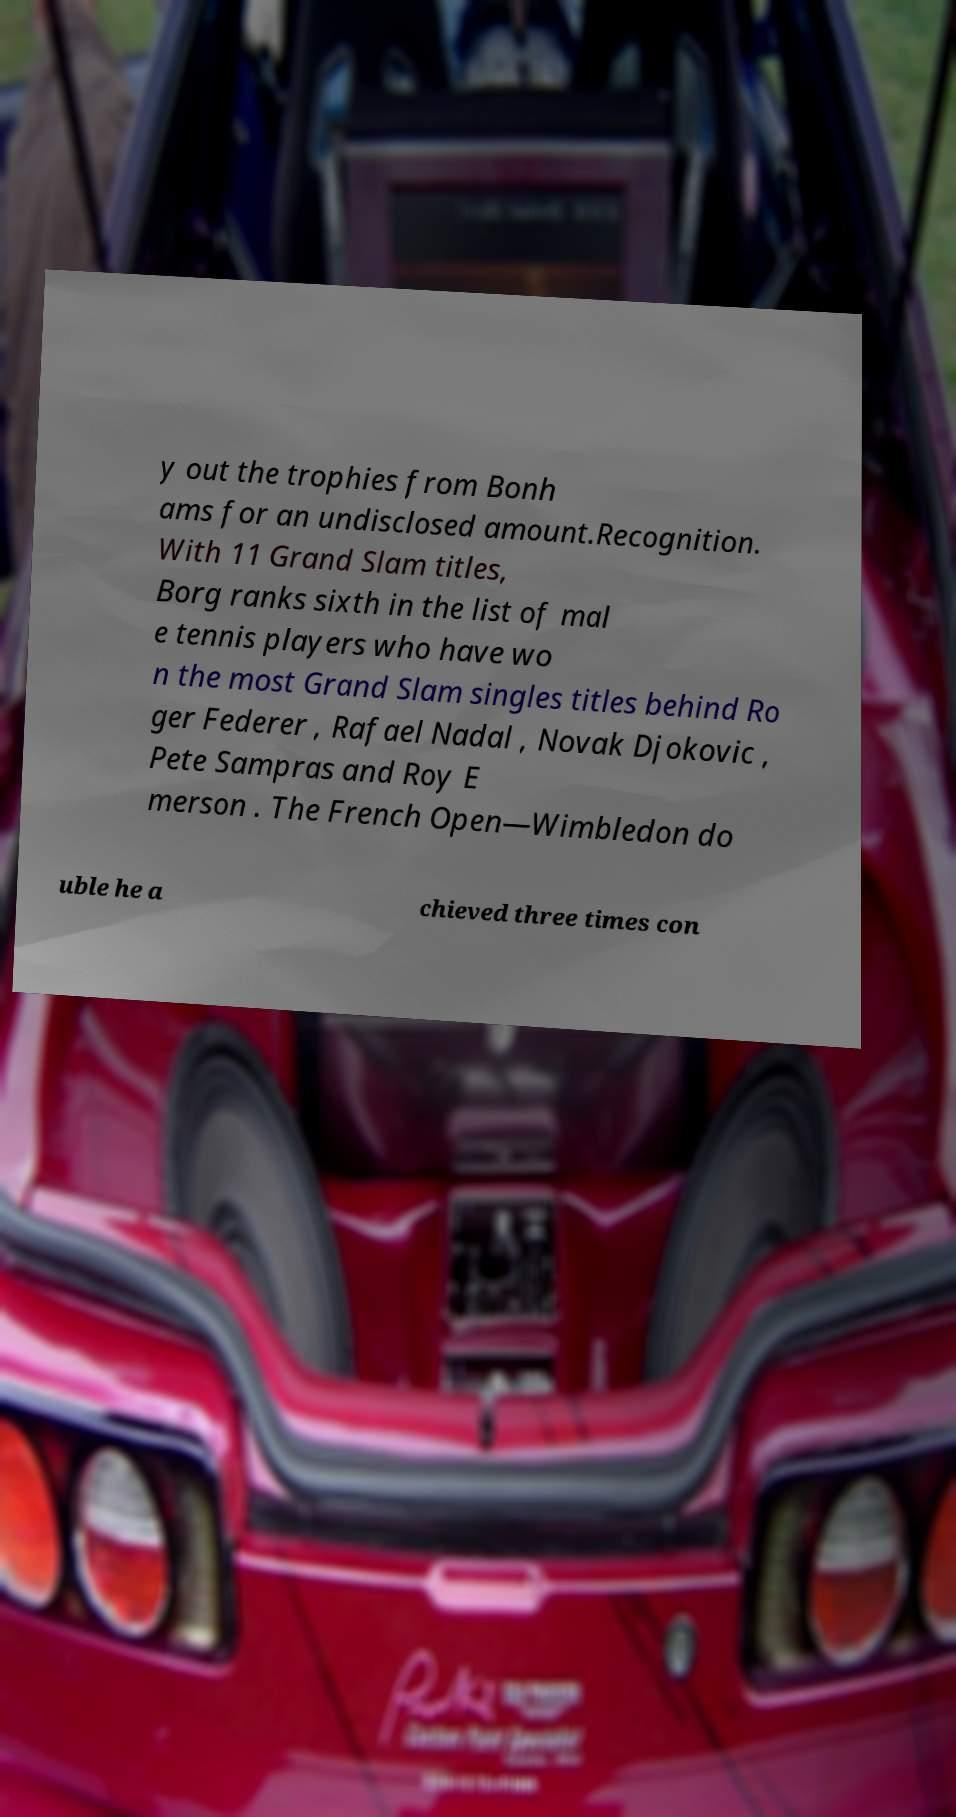Can you accurately transcribe the text from the provided image for me? y out the trophies from Bonh ams for an undisclosed amount.Recognition. With 11 Grand Slam titles, Borg ranks sixth in the list of mal e tennis players who have wo n the most Grand Slam singles titles behind Ro ger Federer , Rafael Nadal , Novak Djokovic , Pete Sampras and Roy E merson . The French Open—Wimbledon do uble he a chieved three times con 